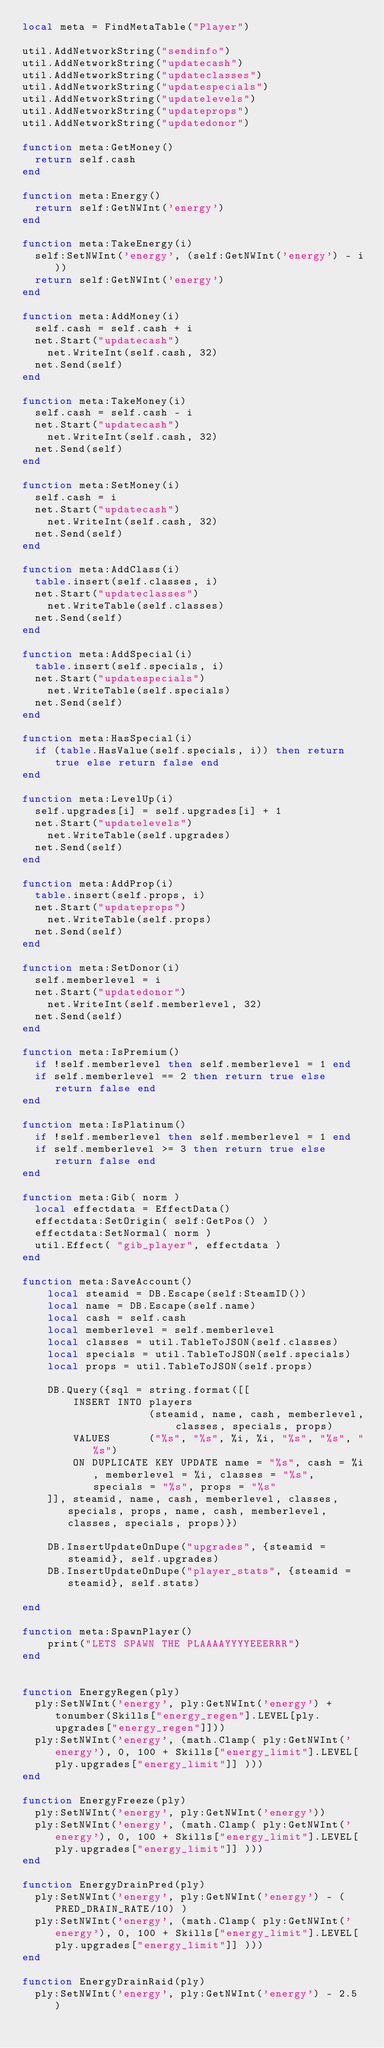Convert code to text. <code><loc_0><loc_0><loc_500><loc_500><_Lua_>local meta = FindMetaTable("Player")

util.AddNetworkString("sendinfo")
util.AddNetworkString("updatecash")
util.AddNetworkString("updateclasses")
util.AddNetworkString("updatespecials")
util.AddNetworkString("updatelevels")
util.AddNetworkString("updateprops")
util.AddNetworkString("updatedonor")

function meta:GetMoney()
	return self.cash
end

function meta:Energy()
	return self:GetNWInt('energy')
end

function meta:TakeEnergy(i)
	self:SetNWInt('energy', (self:GetNWInt('energy') - i))
	return self:GetNWInt('energy')
end

function meta:AddMoney(i)
	self.cash = self.cash + i
	net.Start("updatecash")
		net.WriteInt(self.cash, 32)
	net.Send(self)
end

function meta:TakeMoney(i)
	self.cash = self.cash - i
	net.Start("updatecash")
		net.WriteInt(self.cash, 32)
	net.Send(self)
end

function meta:SetMoney(i)
	self.cash = i
	net.Start("updatecash")
		net.WriteInt(self.cash, 32)
	net.Send(self)
end

function meta:AddClass(i)
	table.insert(self.classes, i)
	net.Start("updateclasses")
		net.WriteTable(self.classes)
	net.Send(self)
end

function meta:AddSpecial(i)
	table.insert(self.specials, i)
	net.Start("updatespecials")
		net.WriteTable(self.specials)
	net.Send(self)
end

function meta:HasSpecial(i)
	if (table.HasValue(self.specials, i)) then return true else return false end
end

function meta:LevelUp(i)
	self.upgrades[i] = self.upgrades[i] + 1
	net.Start("updatelevels")
		net.WriteTable(self.upgrades)
	net.Send(self)
end

function meta:AddProp(i)
	table.insert(self.props, i)
	net.Start("updateprops")
		net.WriteTable(self.props)
	net.Send(self)
end

function meta:SetDonor(i)
	self.memberlevel = i
	net.Start("updatedonor")
		net.WriteInt(self.memberlevel, 32)
	net.Send(self)
end

function meta:IsPremium()
	if !self.memberlevel then self.memberlevel = 1 end
	if self.memberlevel == 2 then return true else return false end
end

function meta:IsPlatinum()
	if !self.memberlevel then self.memberlevel = 1 end
	if self.memberlevel >= 3 then return true else return false end
end

function meta:Gib( norm )
	local effectdata = EffectData()
	effectdata:SetOrigin( self:GetPos() )
	effectdata:SetNormal( norm )
	util.Effect( "gib_player", effectdata )
end

function meta:SaveAccount()
    local steamid = DB.Escape(self:SteamID())
    local name = DB.Escape(self.name)
    local cash = self.cash
    local memberlevel = self.memberlevel
    local classes = util.TableToJSON(self.classes)
    local specials = util.TableToJSON(self.specials)
    local props = util.TableToJSON(self.props)
    
    DB.Query({sql = string.format([[
        INSERT INTO players
                    (steamid, name, cash, memberlevel, classes, specials, props)
        VALUES      ("%s", "%s", %i, %i, "%s", "%s", "%s")
        ON DUPLICATE KEY UPDATE name = "%s", cash = %i, memberlevel = %i, classes = "%s", specials = "%s", props = "%s"
    ]], steamid, name, cash, memberlevel, classes, specials, props, name, cash, memberlevel, classes, specials, props)})
    
    DB.InsertUpdateOnDupe("upgrades", {steamid = steamid}, self.upgrades)
    DB.InsertUpdateOnDupe("player_stats", {steamid = steamid}, self.stats)
    
end

function meta:SpawnPlayer()
    print("LETS SPAWN THE PLAAAAYYYYEEERRR")
end


function EnergyRegen(ply)
	ply:SetNWInt('energy', ply:GetNWInt('energy') + tonumber(Skills["energy_regen"].LEVEL[ply.upgrades["energy_regen"]]))
	ply:SetNWInt('energy', (math.Clamp( ply:GetNWInt('energy'), 0, 100 + Skills["energy_limit"].LEVEL[ply.upgrades["energy_limit"]] )))
end

function EnergyFreeze(ply)
	ply:SetNWInt('energy', ply:GetNWInt('energy'))
	ply:SetNWInt('energy', (math.Clamp( ply:GetNWInt('energy'), 0, 100 + Skills["energy_limit"].LEVEL[ply.upgrades["energy_limit"]] )))
end

function EnergyDrainPred(ply)
	ply:SetNWInt('energy', ply:GetNWInt('energy') - (PRED_DRAIN_RATE/10) )
	ply:SetNWInt('energy', (math.Clamp( ply:GetNWInt('energy'), 0, 100 + Skills["energy_limit"].LEVEL[ply.upgrades["energy_limit"]] )))
end

function EnergyDrainRaid(ply)
	ply:SetNWInt('energy', ply:GetNWInt('energy') - 2.5 )</code> 